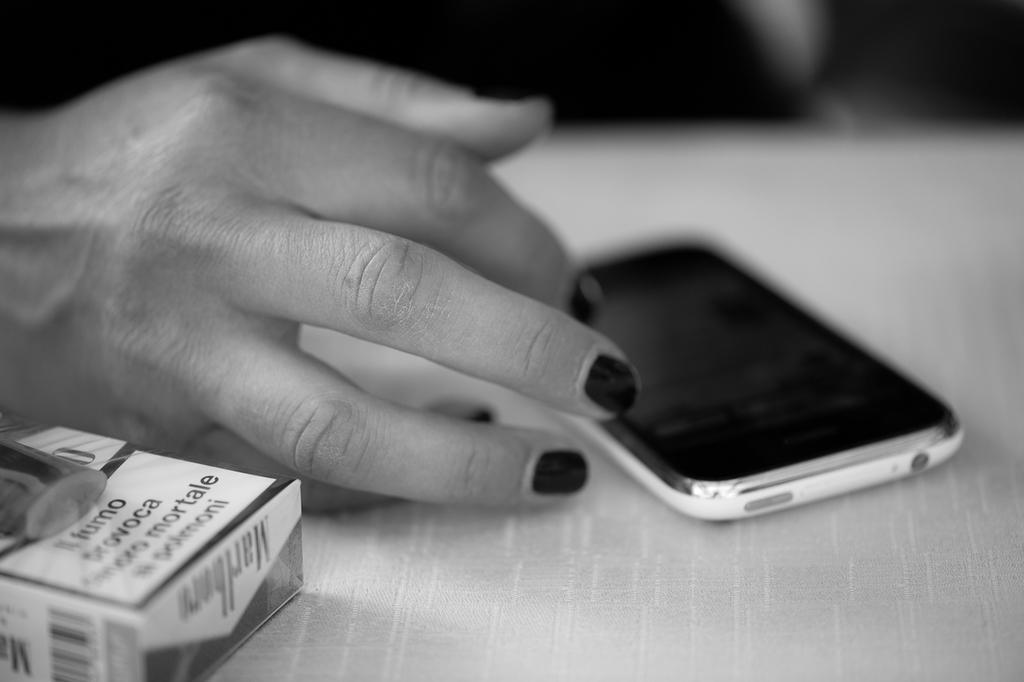Provide a one-sentence caption for the provided image. A cellphone and a packet of Marlborough cigarettes rest on a table. 